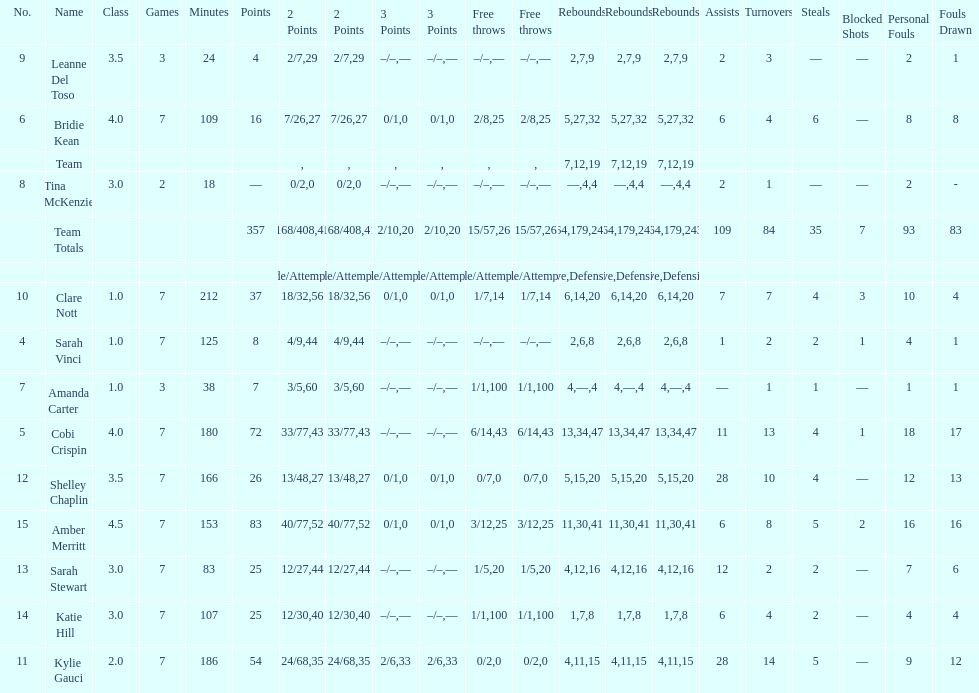After playing seven games, how many players individual points were above 30? 4. 